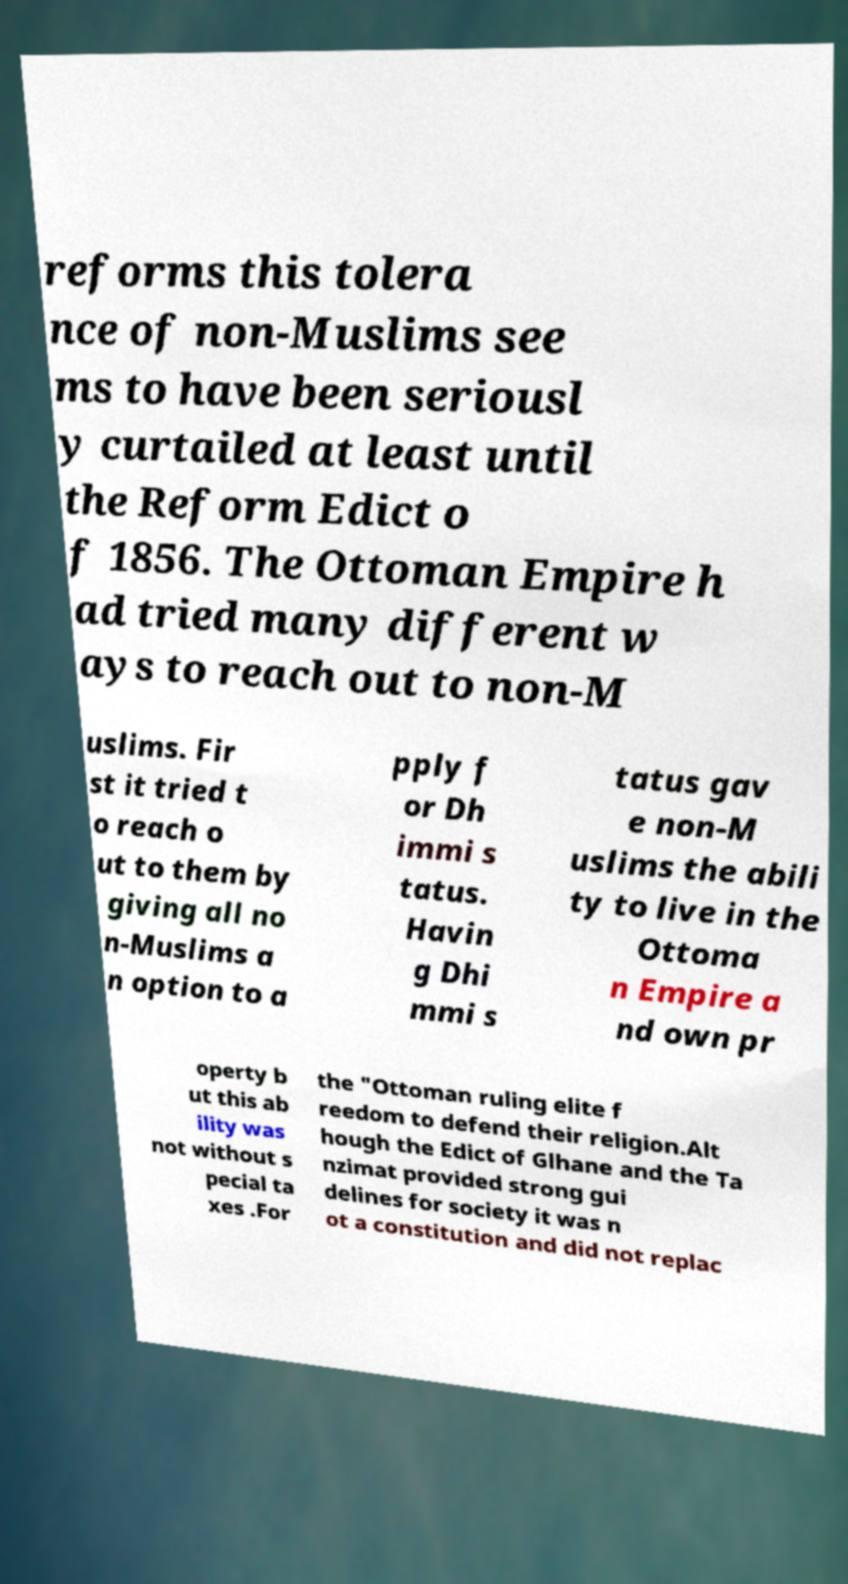Please identify and transcribe the text found in this image. reforms this tolera nce of non-Muslims see ms to have been seriousl y curtailed at least until the Reform Edict o f 1856. The Ottoman Empire h ad tried many different w ays to reach out to non-M uslims. Fir st it tried t o reach o ut to them by giving all no n-Muslims a n option to a pply f or Dh immi s tatus. Havin g Dhi mmi s tatus gav e non-M uslims the abili ty to live in the Ottoma n Empire a nd own pr operty b ut this ab ility was not without s pecial ta xes .For the "Ottoman ruling elite f reedom to defend their religion.Alt hough the Edict of Glhane and the Ta nzimat provided strong gui delines for society it was n ot a constitution and did not replac 